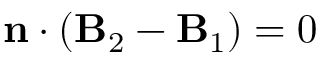<formula> <loc_0><loc_0><loc_500><loc_500>\begin{array} { r l r & { n \cdot \left ( B _ { 2 } - B _ { 1 } \right ) = 0 } \end{array}</formula> 